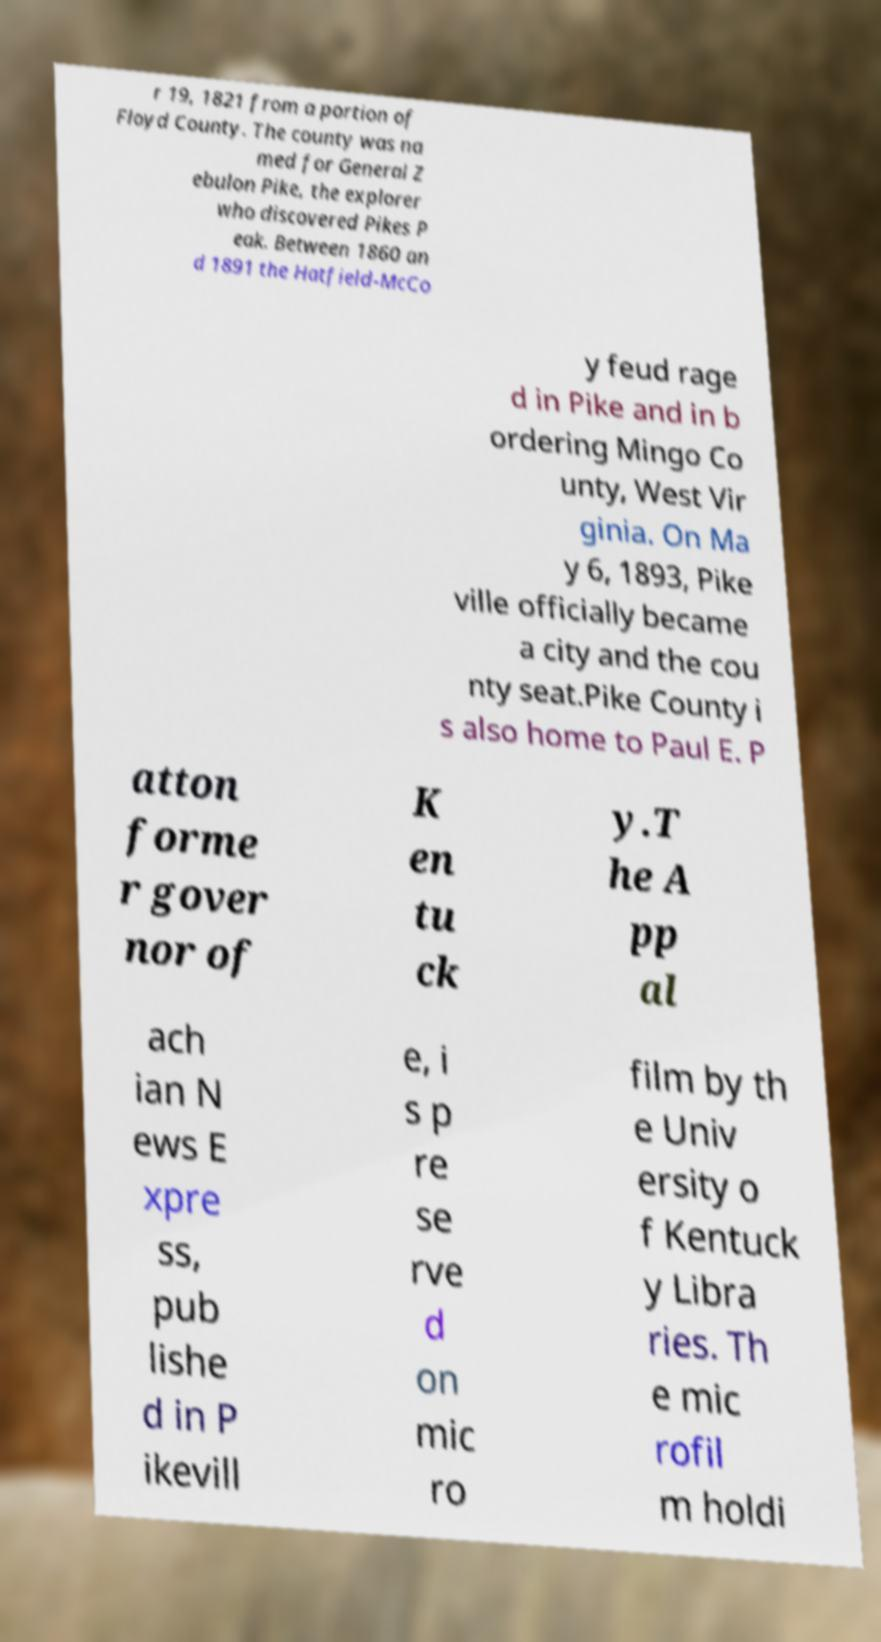There's text embedded in this image that I need extracted. Can you transcribe it verbatim? r 19, 1821 from a portion of Floyd County. The county was na med for General Z ebulon Pike, the explorer who discovered Pikes P eak. Between 1860 an d 1891 the Hatfield-McCo y feud rage d in Pike and in b ordering Mingo Co unty, West Vir ginia. On Ma y 6, 1893, Pike ville officially became a city and the cou nty seat.Pike County i s also home to Paul E. P atton forme r gover nor of K en tu ck y.T he A pp al ach ian N ews E xpre ss, pub lishe d in P ikevill e, i s p re se rve d on mic ro film by th e Univ ersity o f Kentuck y Libra ries. Th e mic rofil m holdi 